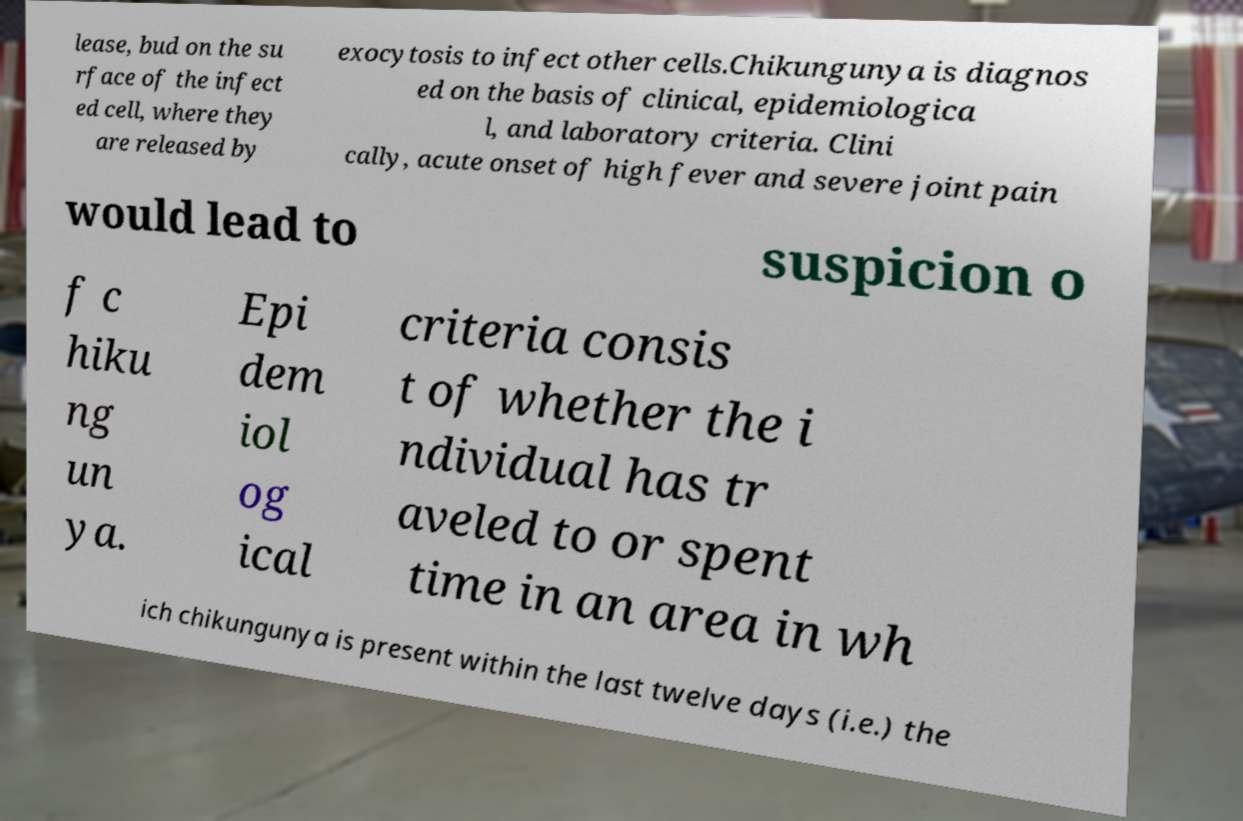For documentation purposes, I need the text within this image transcribed. Could you provide that? lease, bud on the su rface of the infect ed cell, where they are released by exocytosis to infect other cells.Chikungunya is diagnos ed on the basis of clinical, epidemiologica l, and laboratory criteria. Clini cally, acute onset of high fever and severe joint pain would lead to suspicion o f c hiku ng un ya. Epi dem iol og ical criteria consis t of whether the i ndividual has tr aveled to or spent time in an area in wh ich chikungunya is present within the last twelve days (i.e.) the 